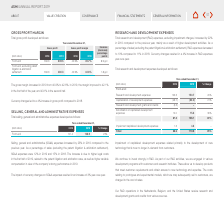From Asm International Nv's financial document, Where are the R&D operations located for the company? The document contains multiple relevant values: Netherlands, Belgium, the United States. From the document: "Our R&D operations in the Netherlands, Belgium, and the United States receive research and Our R&D operations in the Netherlands, Belgium, and the Uni..." Also, What are the years included in the table for Total research and development expenses? The document shows two values: 2018 and 2019. From the document: "(EUR million) 2018 2019 % Change (EUR million) 2018 2019 % Change..." Also, What is the R&D expense as a percentage of sales in 2019? According to the financial document, 10%. The relevant text states: "to 10% compared to 11% in 2018. Currency changes resulted in a 4% increase in R&D expenses..." Additionally, For 2019, What is the segment of Front-end that has the highest expense amount? Research and development expenses. The document states: "Research and development expenses 125.3 150.7 20%..." Also, can you calculate: What is the change in total research and development expenses from 2018 to 2019? Based on the calculation: 110.8-88.6, the result is 22.2 (in millions). This is based on the information: "Total 88.6 110.8 25% Total 88.6 110.8 25%..." The key data points involved are: 110.8, 88.6. Also, can you calculate: For 2019, what is the  Research and development expenses and  Capitalization of development expenses expressed as a percentage of total research and development expenses? To answer this question, I need to perform calculations using the financial data. The calculation is: (150.7+(-60.2))/110.8, which equals 81.68 (percentage). This is based on the information: "Research and development expenses 125.3 150.7 20% Total 88.6 110.8 25% Capitalization of development expenses (49.7) (60.2) 21%..." The key data points involved are: 110.8, 150.7, 60.2. 